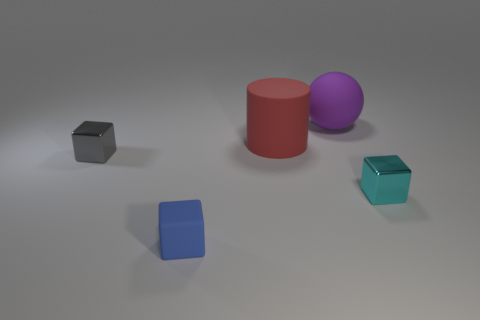What could the arrangement of these shapes suggest about the setting or the purpose of this composition? The arrangement of shapes seems deliberately balanced, with a composition that could suggest a study of geometry and color in a controlled environment, perhaps for an art project or a visual experiment. The muted background and even lighting enhance the focus on the colored geometric forms and could imply an intention to highlight simplicity and form, or to create a tranquil and harmonized scene. 